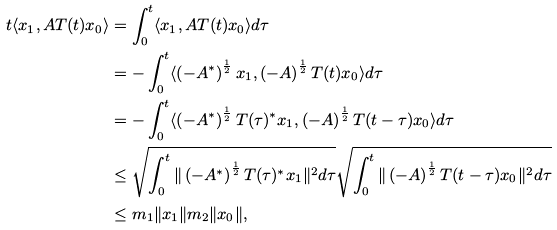<formula> <loc_0><loc_0><loc_500><loc_500>t \langle x _ { 1 } , A T ( t ) x _ { 0 } \rangle & = \int _ { 0 } ^ { t } \langle x _ { 1 } , A T ( t ) x _ { 0 } \rangle d \tau \\ & = - \int _ { 0 } ^ { t } \langle \left ( - A ^ { * } \right ) ^ { \frac { 1 } { 2 } } x _ { 1 } , \left ( - A \right ) ^ { \frac { 1 } { 2 } } T ( t ) x _ { 0 } \rangle d \tau \\ & = - \int _ { 0 } ^ { t } \langle \left ( - A ^ { * } \right ) ^ { \frac { 1 } { 2 } } T ( \tau ) ^ { * } x _ { 1 } , \left ( - A \right ) ^ { \frac { 1 } { 2 } } T ( t - \tau ) x _ { 0 } \rangle d \tau \\ & \leq \sqrt { \int _ { 0 } ^ { t } \| \left ( - A ^ { * } \right ) ^ { \frac { 1 } { 2 } } T ( \tau ) ^ { * } x _ { 1 } \| ^ { 2 } d \tau } \sqrt { \int _ { 0 } ^ { t } \| \left ( - A \right ) ^ { \frac { 1 } { 2 } } T ( t - \tau ) x _ { 0 } \| ^ { 2 } d \tau } \\ & \leq m _ { 1 } \| x _ { 1 } \| m _ { 2 } \| x _ { 0 } \| ,</formula> 